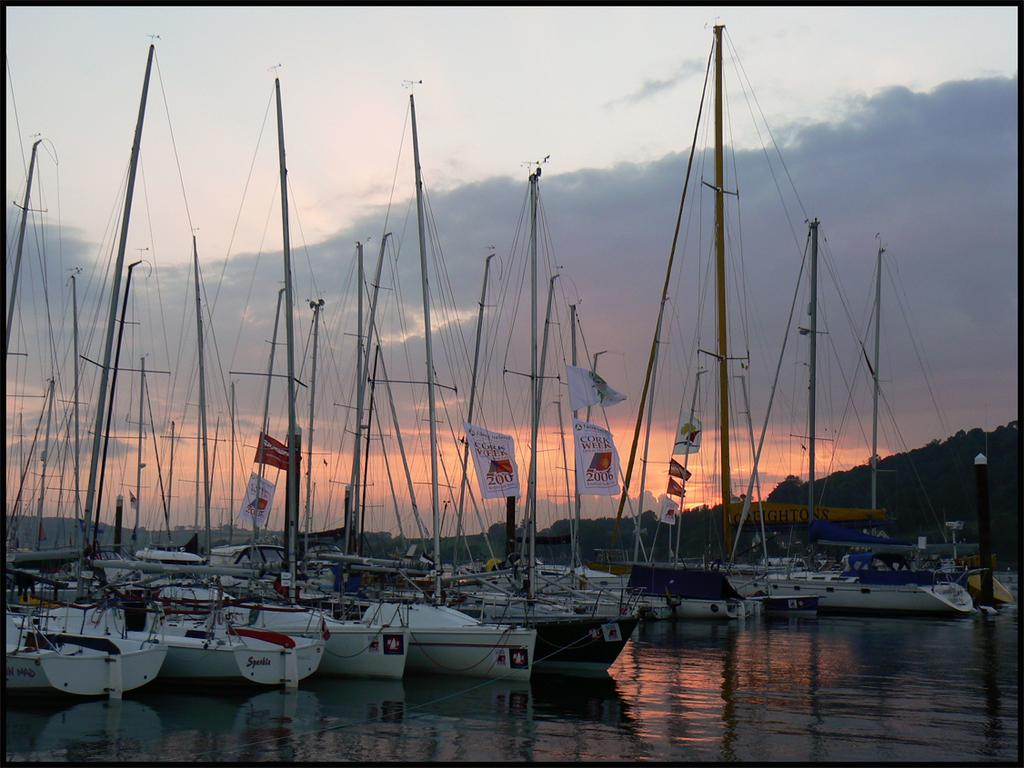<image>
Create a compact narrative representing the image presented. boats in a harbor with flying flags that have the 200 number 